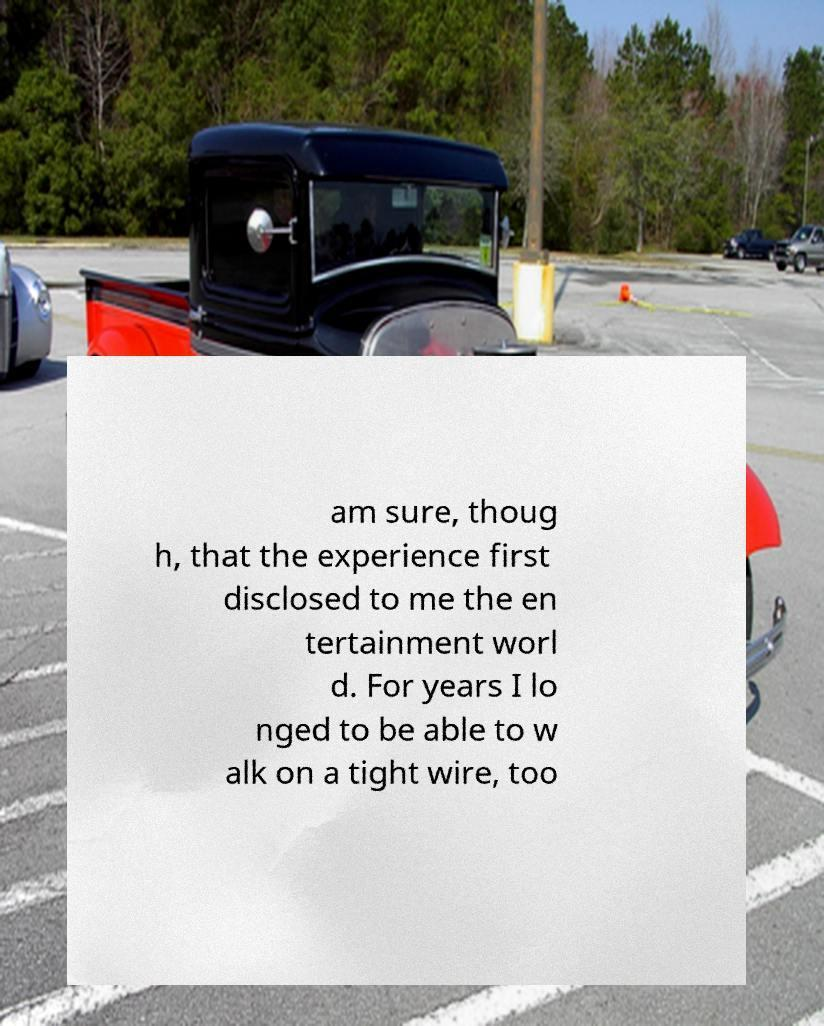Can you read and provide the text displayed in the image?This photo seems to have some interesting text. Can you extract and type it out for me? am sure, thoug h, that the experience first disclosed to me the en tertainment worl d. For years I lo nged to be able to w alk on a tight wire, too 